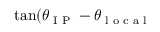<formula> <loc_0><loc_0><loc_500><loc_500>\tan ( \theta _ { I P } - \theta _ { l o c a l }</formula> 